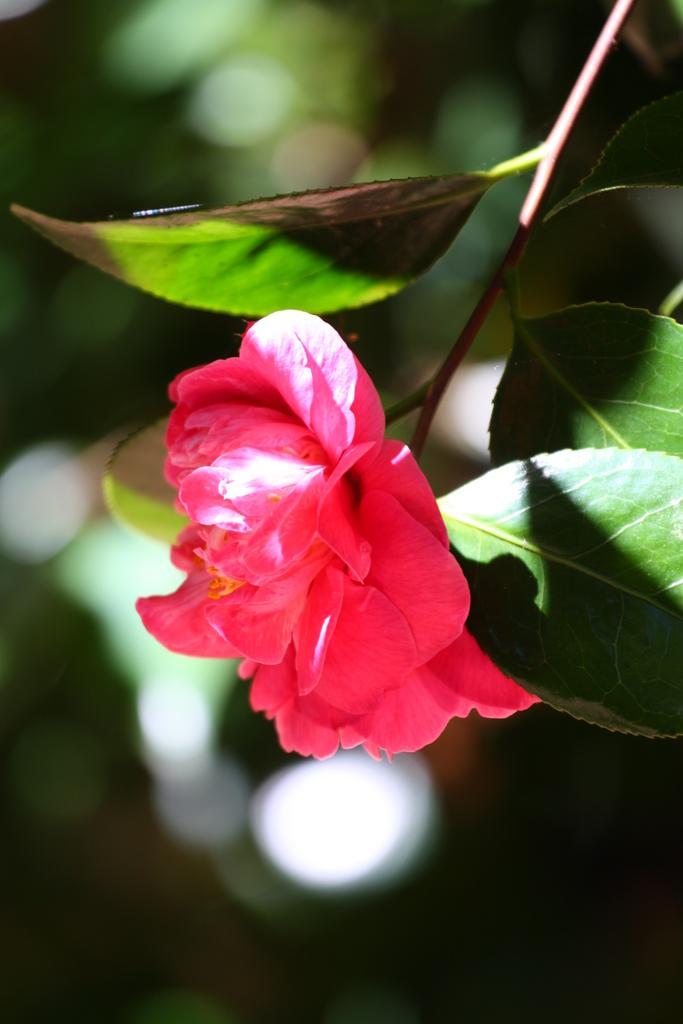In one or two sentences, can you explain what this image depicts? In this image we can see a flower, leaves and stem. In the background the image is blur. 